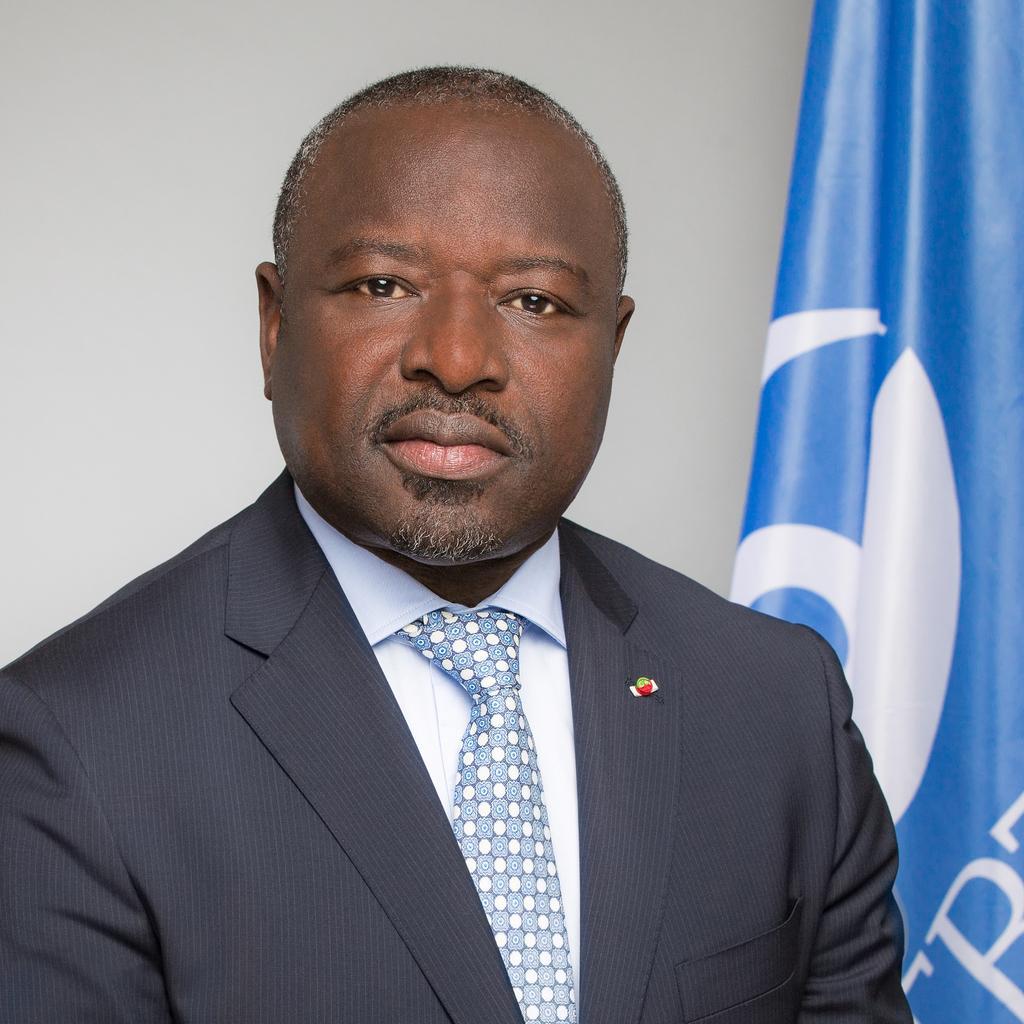In one or two sentences, can you explain what this image depicts? In this image I can see the person wearing the blazer, shirt and the tie. In the background I can see the blue and white color flag and the wall. 